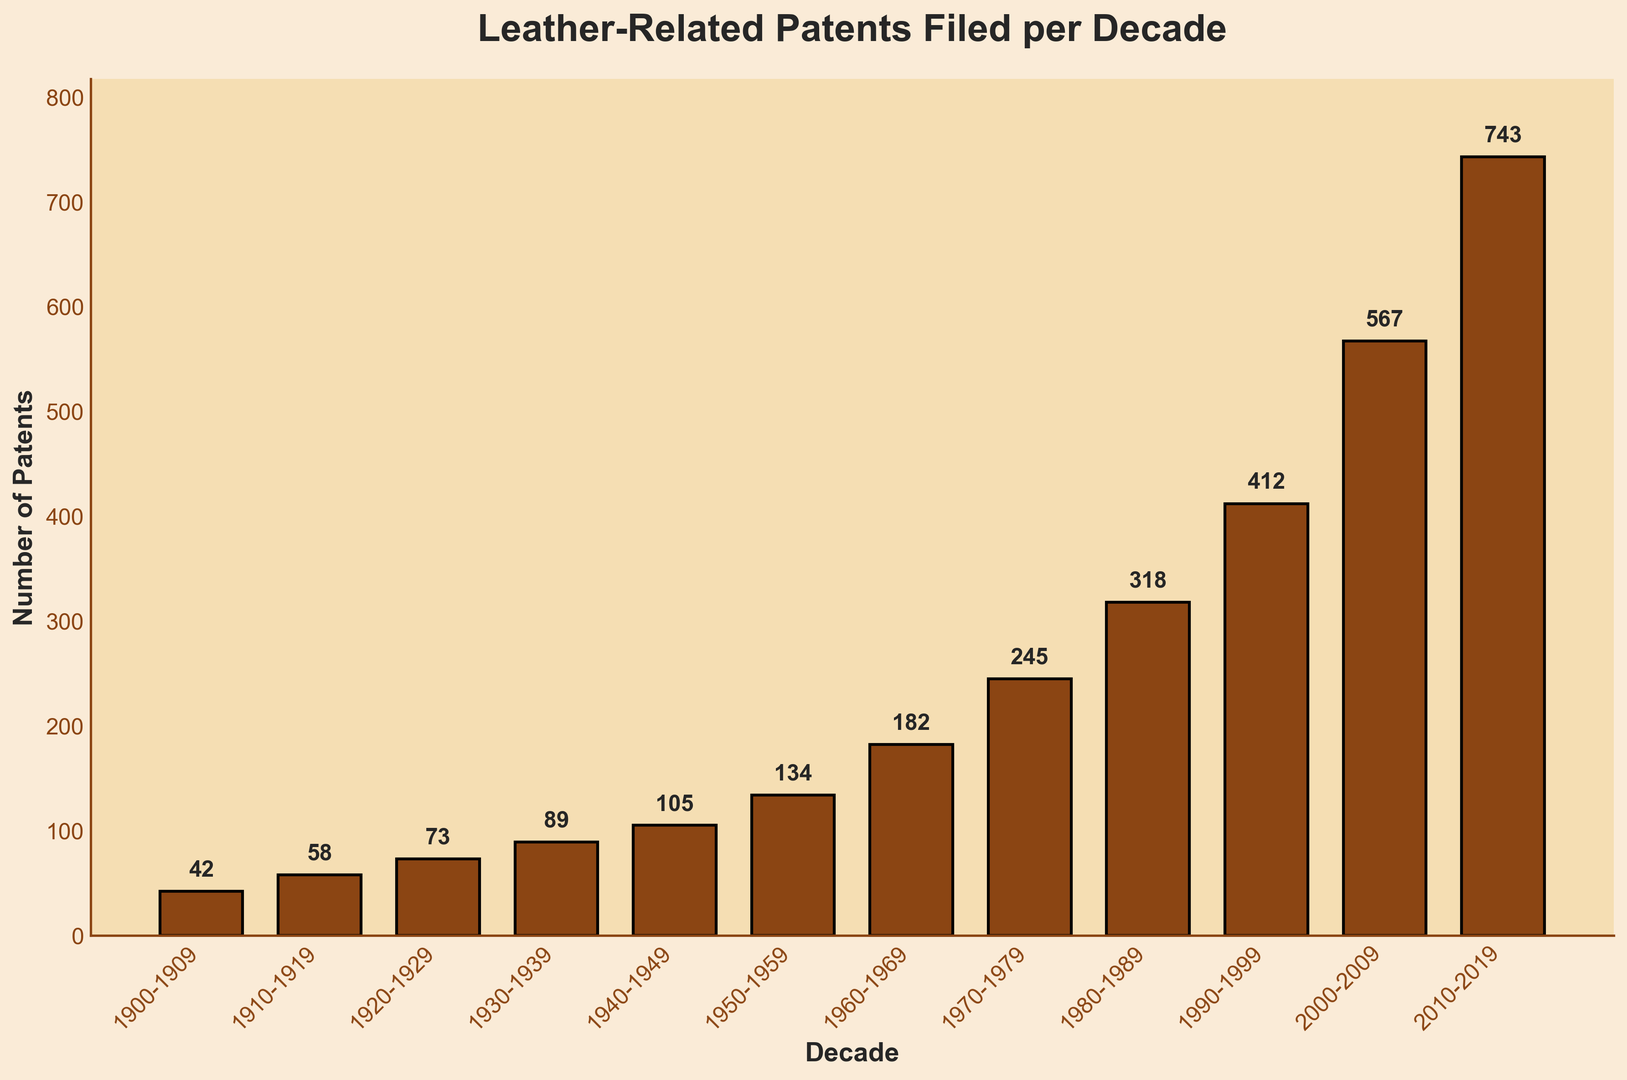Which decade had the highest number of leather-related patents filed? To determine the decade with the highest number of patents, look for the tallest bar in the histogram. The bar with a value of 743 represents the 2010-2019 decade.
Answer: 2010-2019 Which decade saw the largest increase in the number of leather-related patents compared to the previous decade? To find the largest increase, calculate the difference in the number of patents between consecutive decades. The highest difference is between 2000-2009 (567 patents) and 2010-2019 (743 patents), which is an increase of 176.
Answer: 2010-2019 What is the total number of leather-related patents filed from 1900 to 1949? Sum the number of patents for the decades 1900-1909, 1910-1919, 1920-1929, 1930-1939, and 1940-1949: 42 + 58 + 73 + 89 + 105 = 367.
Answer: 367 How does the number of patents filed in the 1970s compare to those filed in the 1980s? Compare the count of patents from 1970-1979 (245 patents) and 1980-1989 (318 patents). The 1980s had more patents, with a difference of 318 - 245 = 73.
Answer: 1980s had 73 more patents Which decades have fewer than 100 leather-related patents filed? Identify the bars with heights less than 100: 1900-1909 (42 patents), 1910-1919 (58 patents), and 1920-1929 (73 patents).
Answer: 1900-1909, 1910-1919, 1920-1929 What is the average number of patents filed per decade from 1900 to 2019? Calculate the sum of all patents and divide by the number of decades. The total patents from 1900-2019 is 42 + 58 + 73 + 89 + 105 + 134 + 182 + 245 + 318 + 412 + 567 + 743 = 2968, and there are 12 decades. So, the average is 2968 / 12 = 247.33.
Answer: 247.33 Which color represents the bars in the histogram? The bars in the histogram are colored in brown, representing leather.
Answer: Brown 